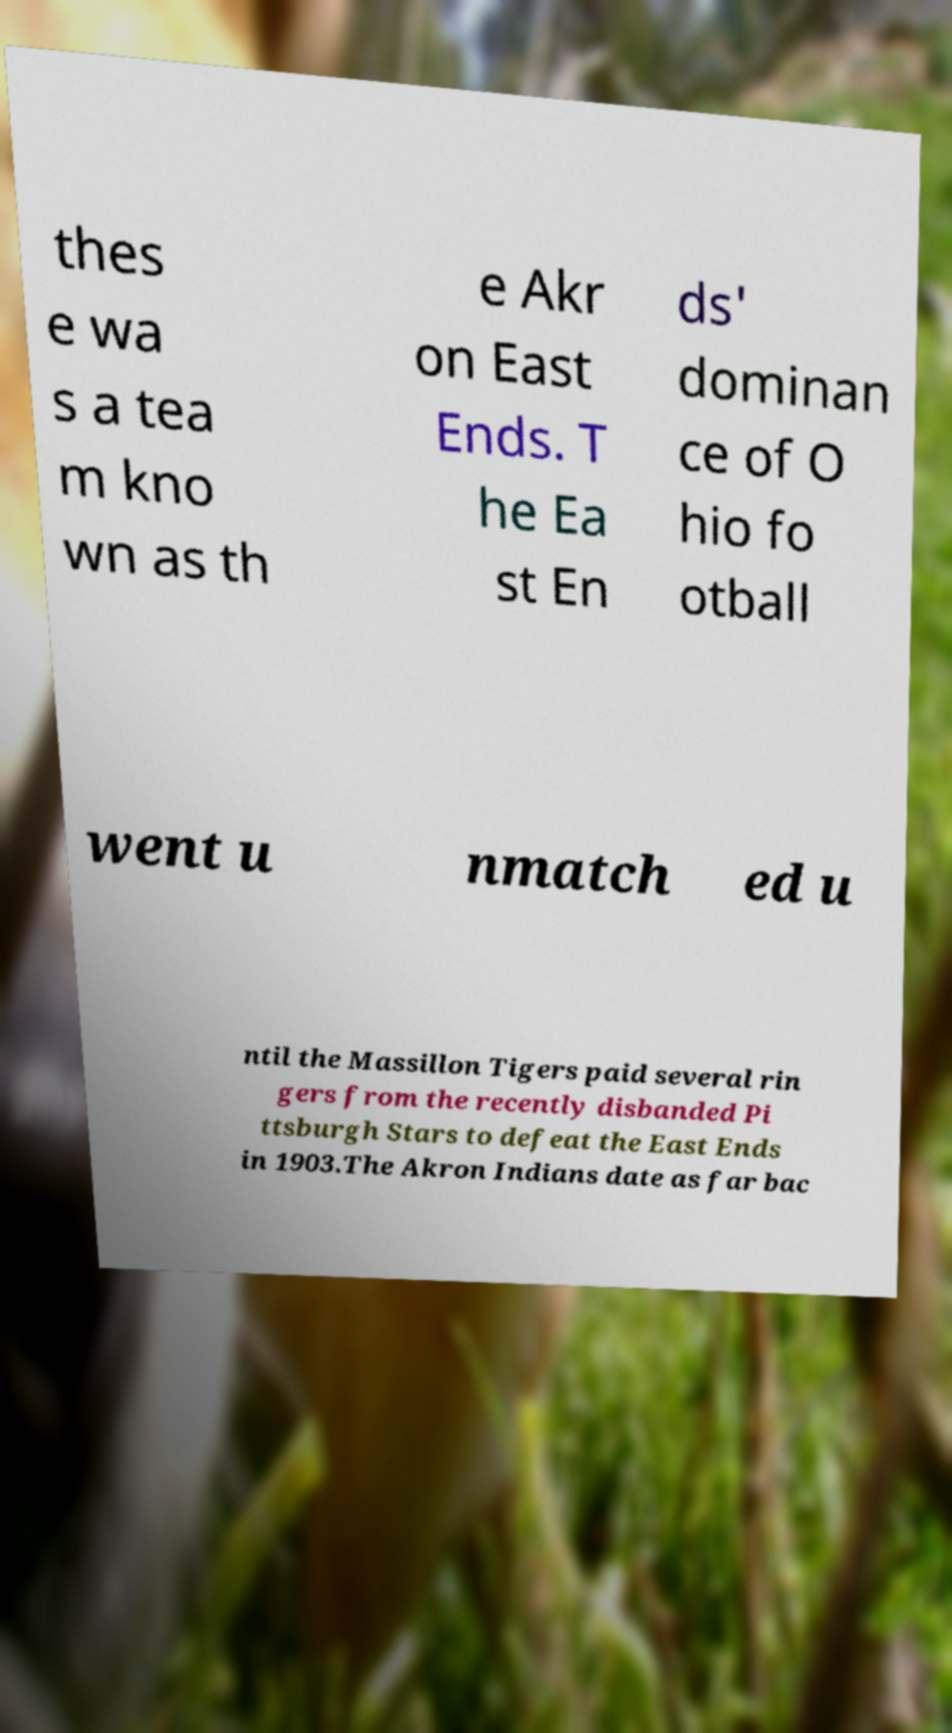Please identify and transcribe the text found in this image. thes e wa s a tea m kno wn as th e Akr on East Ends. T he Ea st En ds' dominan ce of O hio fo otball went u nmatch ed u ntil the Massillon Tigers paid several rin gers from the recently disbanded Pi ttsburgh Stars to defeat the East Ends in 1903.The Akron Indians date as far bac 